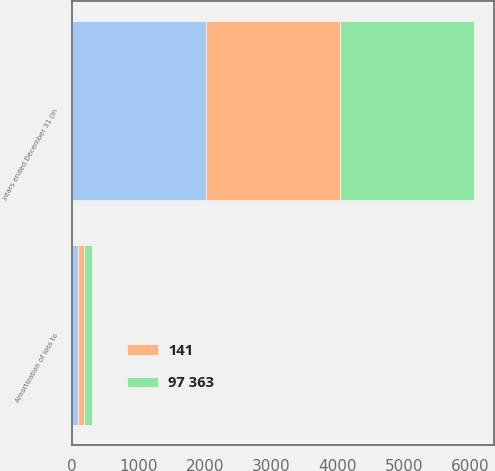<chart> <loc_0><loc_0><loc_500><loc_500><stacked_bar_chart><ecel><fcel>years ended December 31 (in<fcel>Amortization of loss to<nl><fcel>nan<fcel>2017<fcel>91<nl><fcel>141<fcel>2016<fcel>94<nl><fcel>97 363<fcel>2015<fcel>120<nl></chart> 